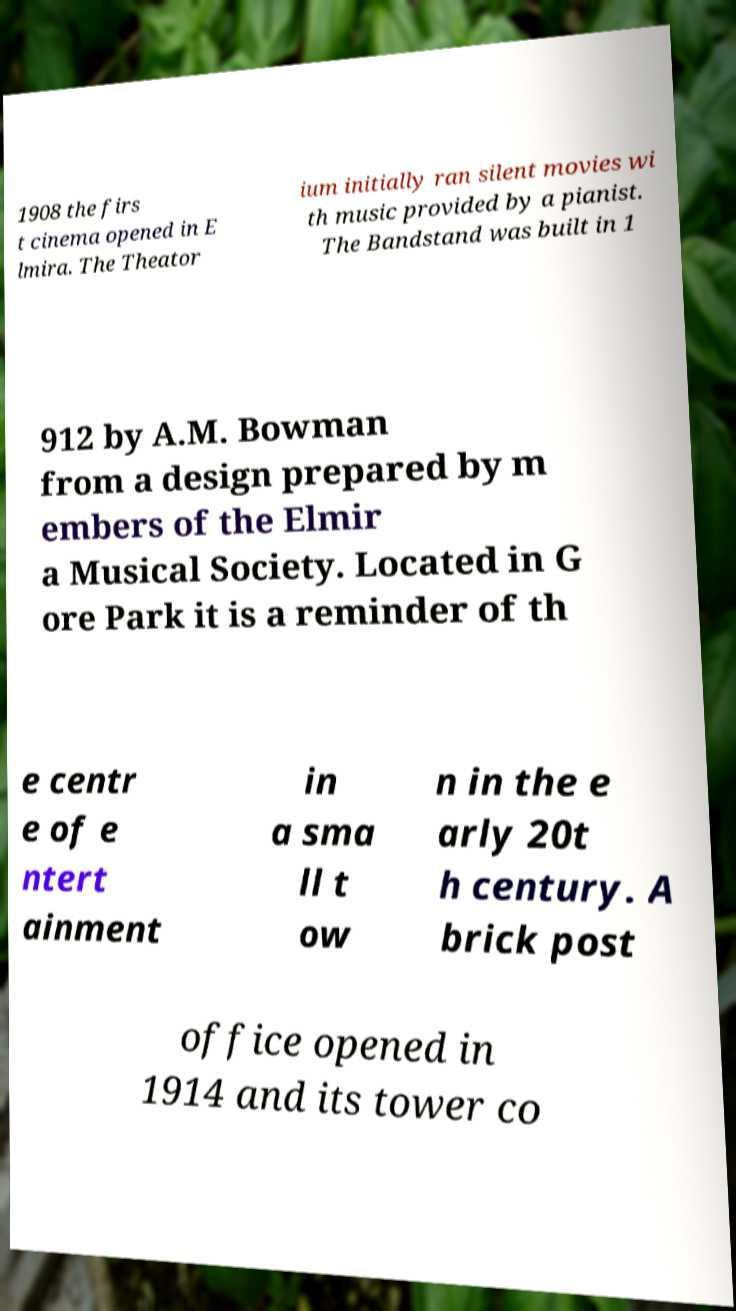Please read and relay the text visible in this image. What does it say? 1908 the firs t cinema opened in E lmira. The Theator ium initially ran silent movies wi th music provided by a pianist. The Bandstand was built in 1 912 by A.M. Bowman from a design prepared by m embers of the Elmir a Musical Society. Located in G ore Park it is a reminder of th e centr e of e ntert ainment in a sma ll t ow n in the e arly 20t h century. A brick post office opened in 1914 and its tower co 